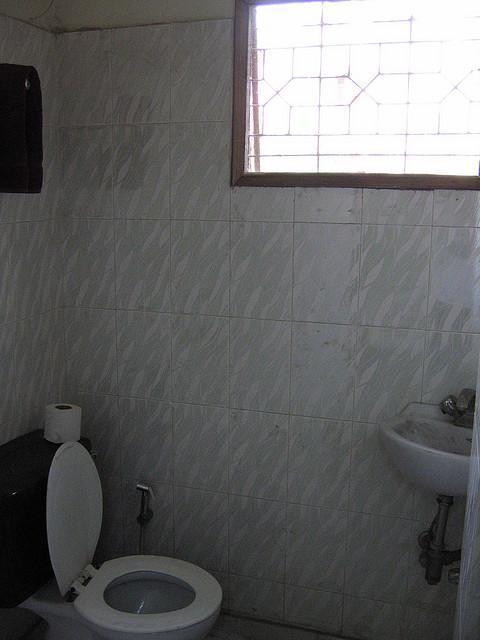How many toilets are visible?
Give a very brief answer. 1. How many paper items are there?
Give a very brief answer. 1. How many dogs are in the picture?
Give a very brief answer. 0. 